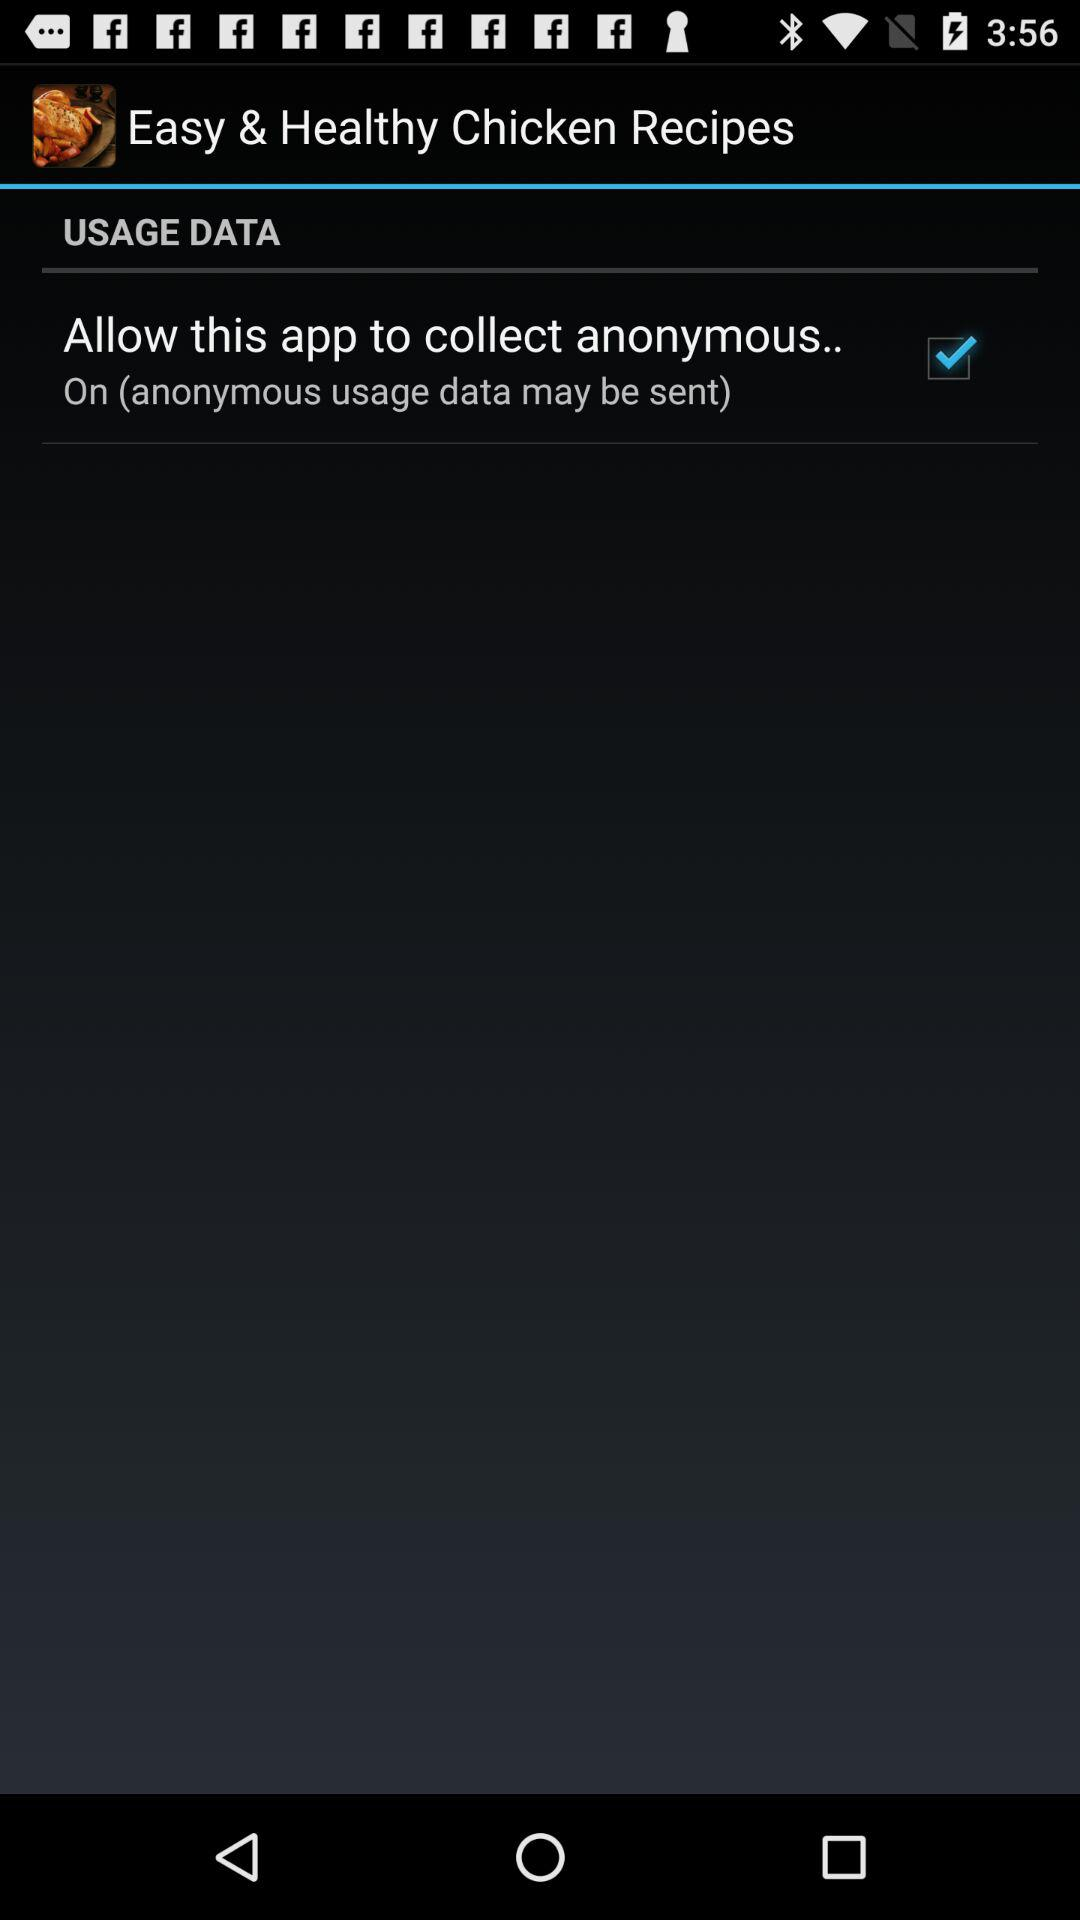What is the status of the "Allow this app to collect anonymous.."? The status is "on". 